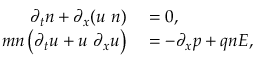<formula> <loc_0><loc_0><loc_500><loc_500>\begin{array} { r l } { \partial _ { t } n + \partial _ { x } ( u n ) } & = 0 , } \\ { m n \left ( \partial _ { t } u + u \partial _ { x } u \right ) } & = - \partial _ { x } p + q n E , } \end{array}</formula> 